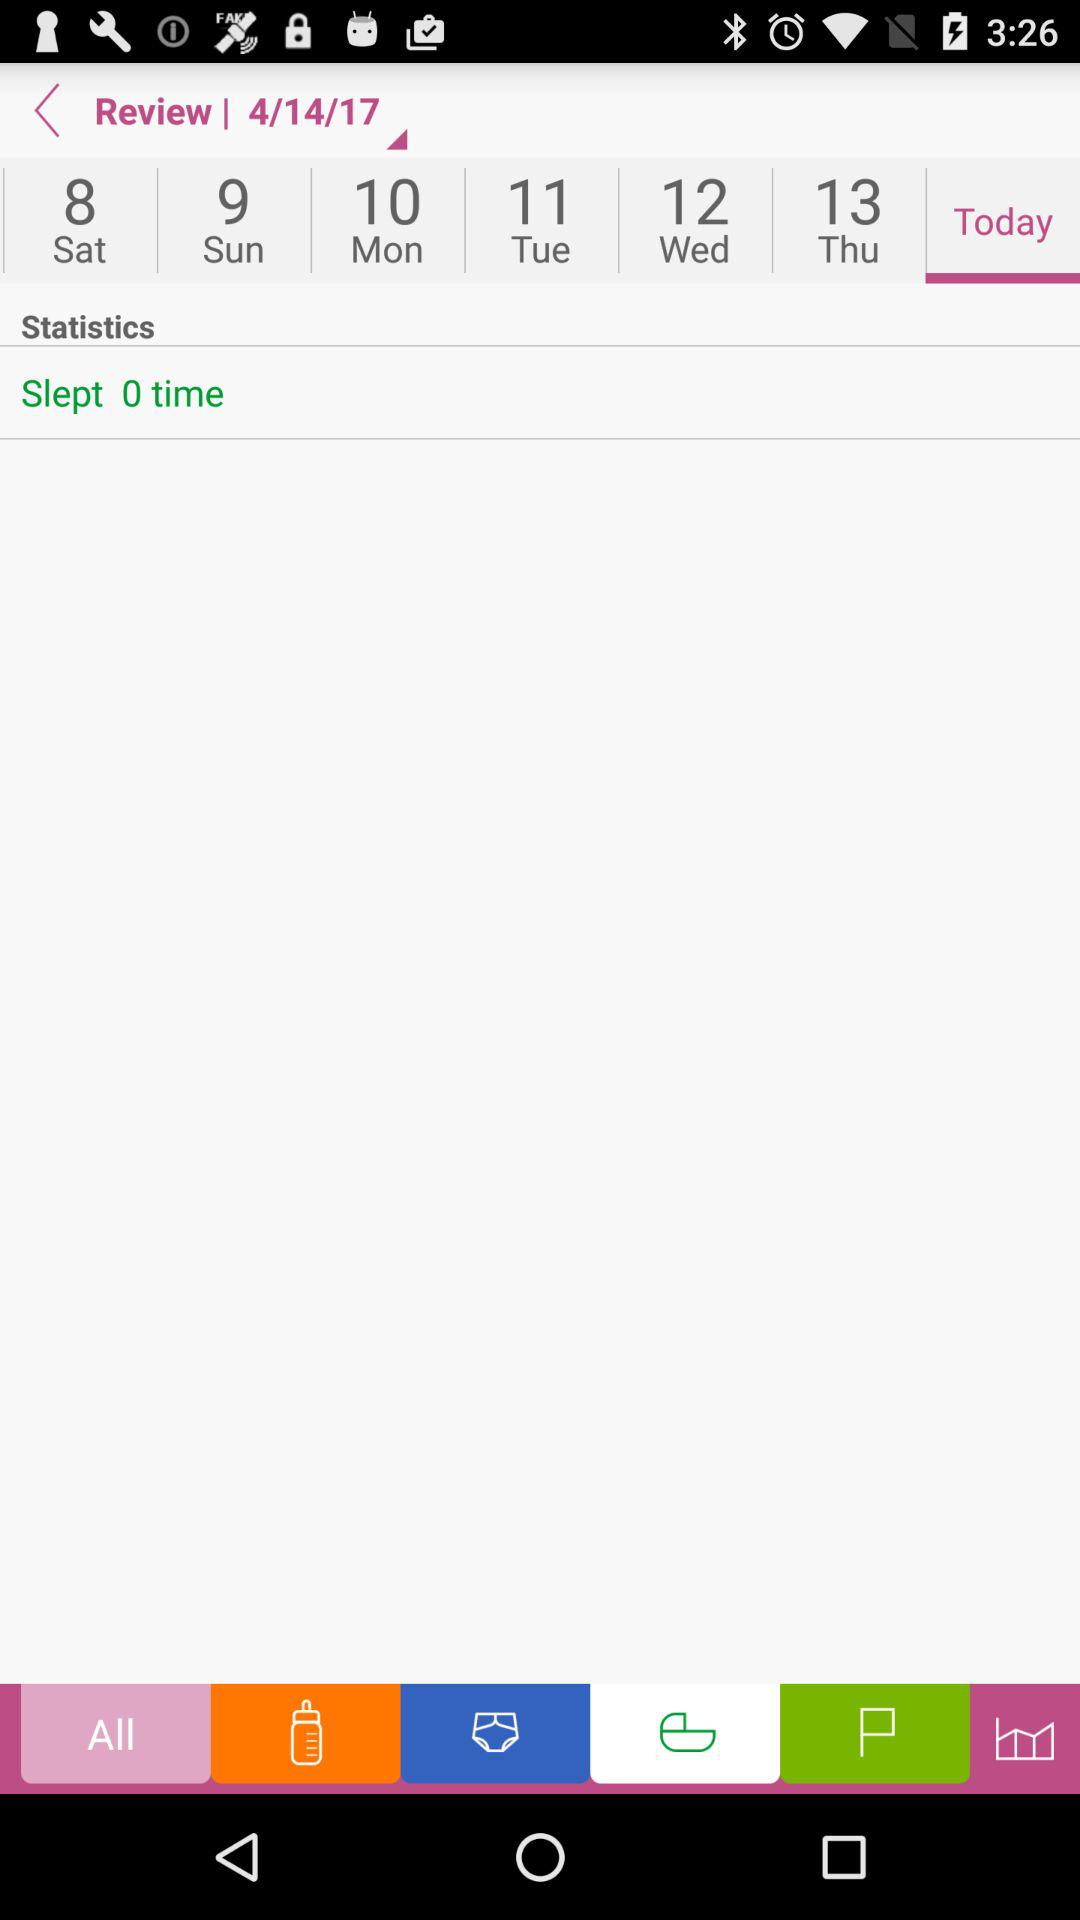On which date does Sunday fall? Sunday falls on April 9, 2017. 